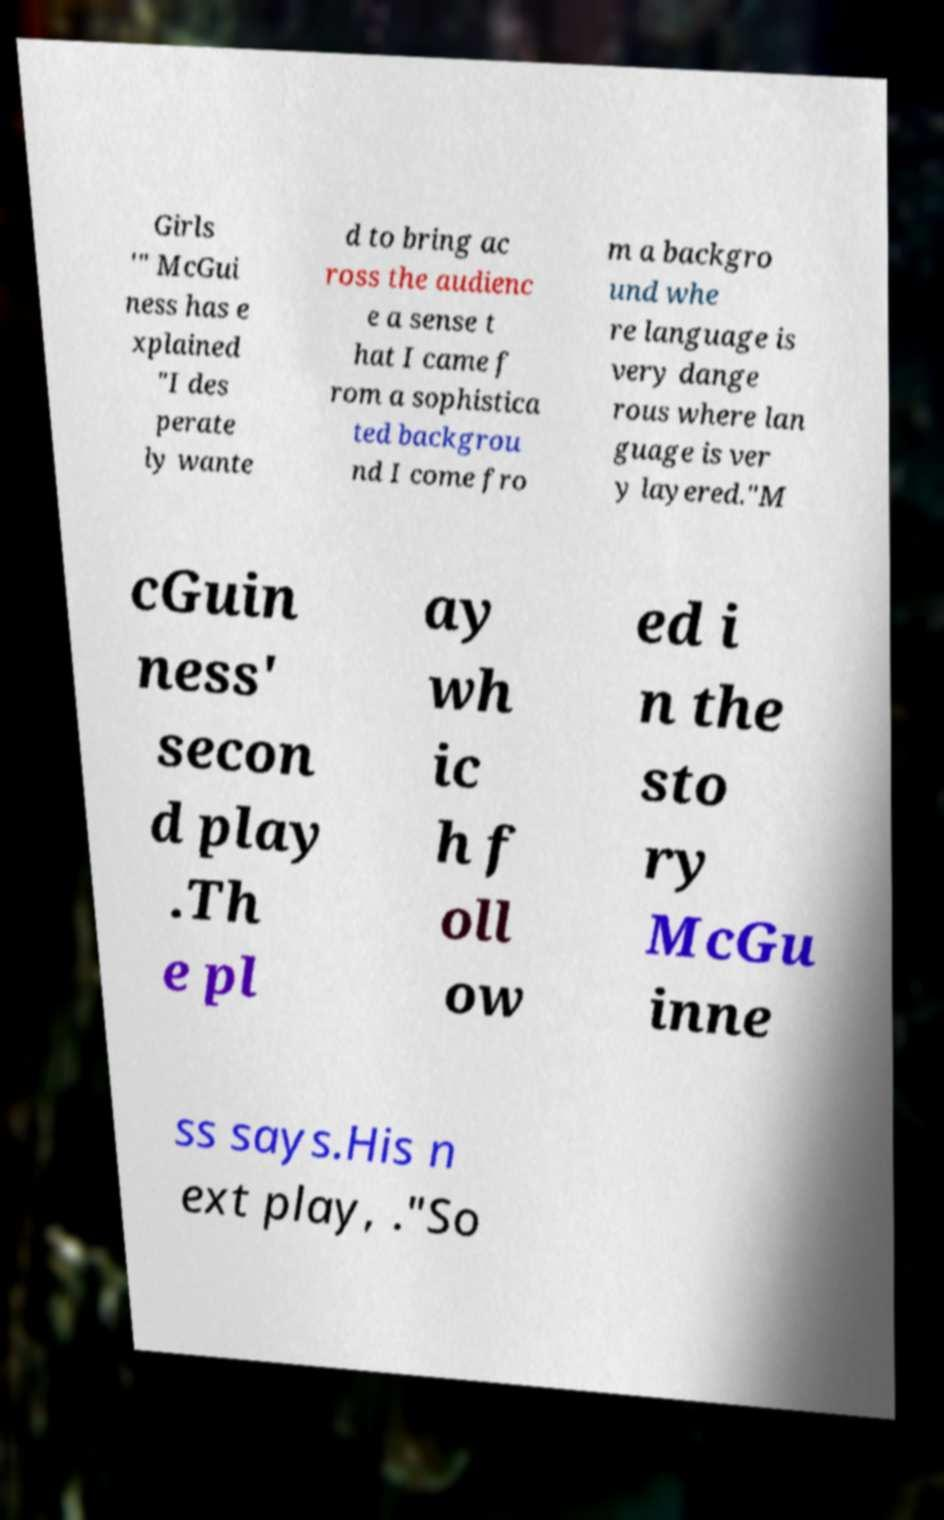Could you assist in decoding the text presented in this image and type it out clearly? Girls '" McGui ness has e xplained "I des perate ly wante d to bring ac ross the audienc e a sense t hat I came f rom a sophistica ted backgrou nd I come fro m a backgro und whe re language is very dange rous where lan guage is ver y layered."M cGuin ness' secon d play .Th e pl ay wh ic h f oll ow ed i n the sto ry McGu inne ss says.His n ext play, ."So 